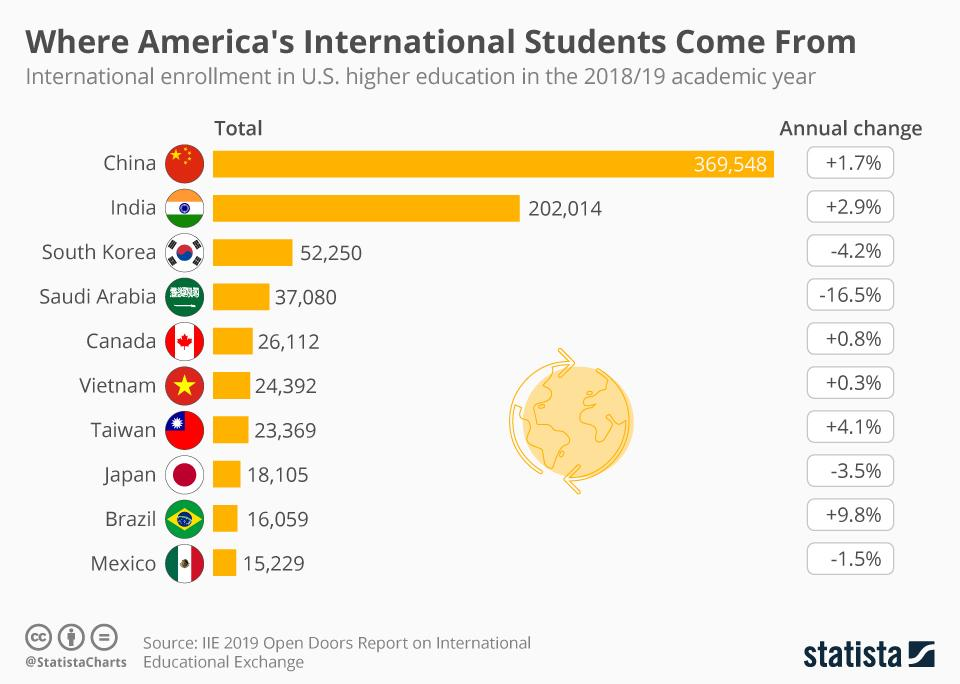Highlight a few significant elements in this photo. India has the second-highest number of students who pursue higher education in America. A significant decrease in the number of students from Saudi Arabia studying in the United States for higher education has been reported. In America, a total of 2,54,264 students from India and South Korea are currently studying together. Brazil has the highest increase in the number of students heading to the United States for higher education. Canada has the fifth-highest number of students who choose to pursue higher education in the United States. 